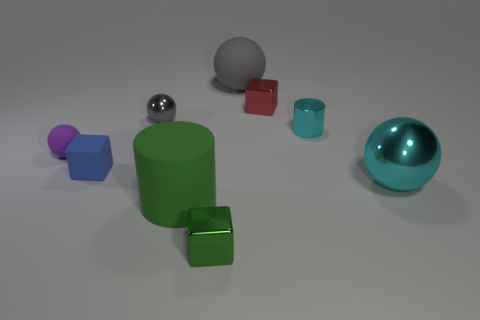What is the size of the sphere that is the same color as the tiny cylinder?
Your response must be concise. Large. There is a tiny metallic cylinder on the right side of the small purple object; is it the same color as the large shiny thing?
Offer a terse response. Yes. The thing that is the same color as the matte cylinder is what shape?
Provide a short and direct response. Cube. Are the small green object and the purple thing made of the same material?
Provide a short and direct response. No. The big rubber thing behind the small thing right of the tiny metallic cube that is behind the large cyan thing is what shape?
Keep it short and to the point. Sphere. Is the number of cyan things in front of the small cyan shiny object less than the number of gray things that are behind the small green cube?
Your answer should be compact. Yes. The big matte object in front of the metal thing that is left of the small green cube is what shape?
Provide a succinct answer. Cylinder. Are there any other things that have the same color as the large cylinder?
Keep it short and to the point. Yes. Does the big cylinder have the same color as the small cylinder?
Offer a very short reply. No. What number of green things are either tiny metal blocks or cubes?
Provide a short and direct response. 1. 